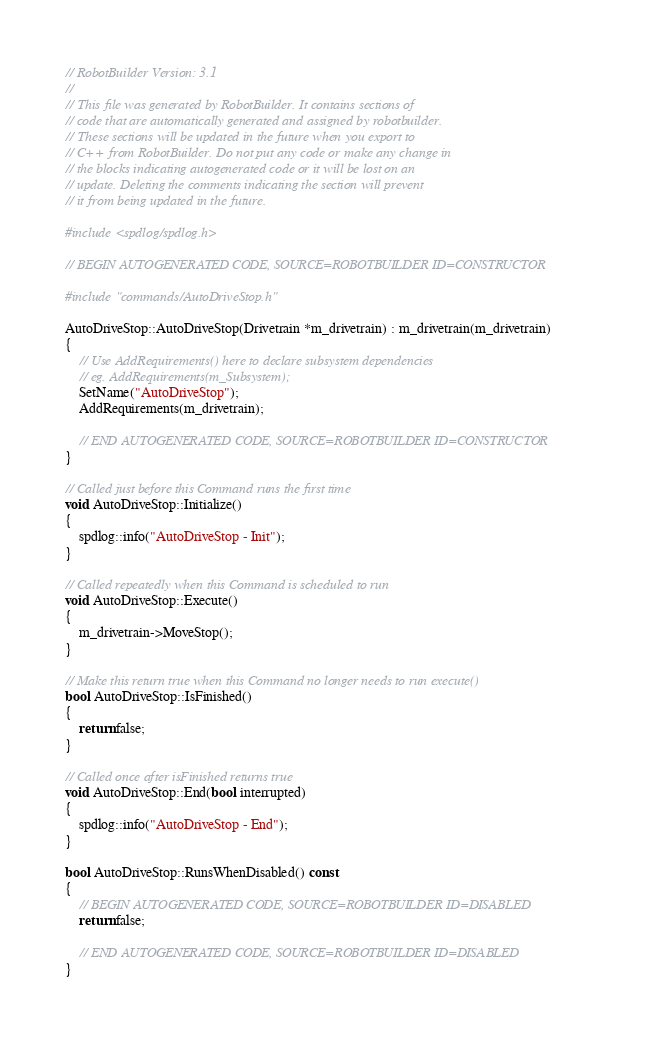Convert code to text. <code><loc_0><loc_0><loc_500><loc_500><_C++_>// RobotBuilder Version: 3.1
//
// This file was generated by RobotBuilder. It contains sections of
// code that are automatically generated and assigned by robotbuilder.
// These sections will be updated in the future when you export to
// C++ from RobotBuilder. Do not put any code or make any change in
// the blocks indicating autogenerated code or it will be lost on an
// update. Deleting the comments indicating the section will prevent
// it from being updated in the future.

#include <spdlog/spdlog.h>

// BEGIN AUTOGENERATED CODE, SOURCE=ROBOTBUILDER ID=CONSTRUCTOR

#include "commands/AutoDriveStop.h"

AutoDriveStop::AutoDriveStop(Drivetrain *m_drivetrain) : m_drivetrain(m_drivetrain)
{
    // Use AddRequirements() here to declare subsystem dependencies
    // eg. AddRequirements(m_Subsystem);
    SetName("AutoDriveStop");
    AddRequirements(m_drivetrain);

    // END AUTOGENERATED CODE, SOURCE=ROBOTBUILDER ID=CONSTRUCTOR
}

// Called just before this Command runs the first time
void AutoDriveStop::Initialize()
{
    spdlog::info("AutoDriveStop - Init");
}

// Called repeatedly when this Command is scheduled to run
void AutoDriveStop::Execute()
{
    m_drivetrain->MoveStop();
}

// Make this return true when this Command no longer needs to run execute()
bool AutoDriveStop::IsFinished()
{
    return false;
}

// Called once after isFinished returns true
void AutoDriveStop::End(bool interrupted)
{
    spdlog::info("AutoDriveStop - End");
}

bool AutoDriveStop::RunsWhenDisabled() const
{
    // BEGIN AUTOGENERATED CODE, SOURCE=ROBOTBUILDER ID=DISABLED
    return false;

    // END AUTOGENERATED CODE, SOURCE=ROBOTBUILDER ID=DISABLED
}
</code> 